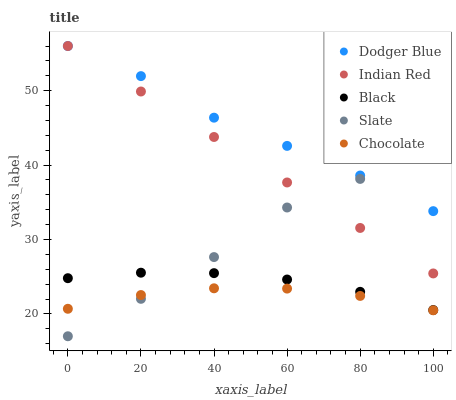Does Chocolate have the minimum area under the curve?
Answer yes or no. Yes. Does Dodger Blue have the maximum area under the curve?
Answer yes or no. Yes. Does Slate have the minimum area under the curve?
Answer yes or no. No. Does Slate have the maximum area under the curve?
Answer yes or no. No. Is Indian Red the smoothest?
Answer yes or no. Yes. Is Slate the roughest?
Answer yes or no. Yes. Is Dodger Blue the smoothest?
Answer yes or no. No. Is Dodger Blue the roughest?
Answer yes or no. No. Does Slate have the lowest value?
Answer yes or no. Yes. Does Dodger Blue have the lowest value?
Answer yes or no. No. Does Indian Red have the highest value?
Answer yes or no. Yes. Does Slate have the highest value?
Answer yes or no. No. Is Chocolate less than Black?
Answer yes or no. Yes. Is Indian Red greater than Black?
Answer yes or no. Yes. Does Black intersect Slate?
Answer yes or no. Yes. Is Black less than Slate?
Answer yes or no. No. Is Black greater than Slate?
Answer yes or no. No. Does Chocolate intersect Black?
Answer yes or no. No. 